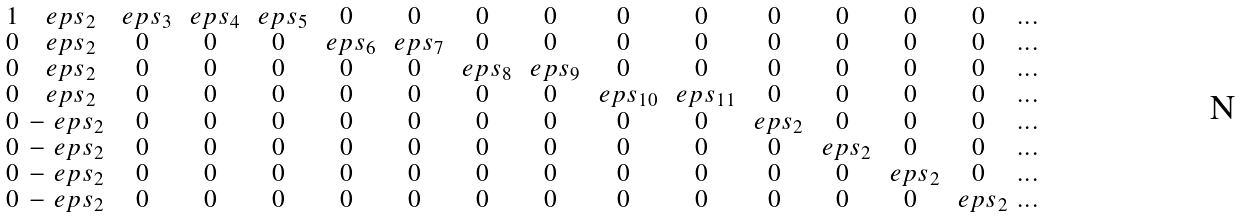Convert formula to latex. <formula><loc_0><loc_0><loc_500><loc_500>\begin{smallmatrix} 1 & \ e p s _ { 2 } & \ e p s _ { 3 } & \ e p s _ { 4 } & \ e p s _ { 5 } & 0 & 0 & 0 & 0 & 0 & 0 & 0 & 0 & 0 & 0 & \dots \\ 0 & \ e p s _ { 2 } & 0 & 0 & 0 & \ e p s _ { 6 } & \ e p s _ { 7 } & 0 & 0 & 0 & 0 & 0 & 0 & 0 & 0 & \dots \\ 0 & \ e p s _ { 2 } & 0 & 0 & 0 & 0 & 0 & \ e p s _ { 8 } & \ e p s _ { 9 } & 0 & 0 & 0 & 0 & 0 & 0 & \dots \\ 0 & \ e p s _ { 2 } & 0 & 0 & 0 & 0 & 0 & 0 & 0 & \ e p s _ { 1 0 } & \ e p s _ { 1 1 } & 0 & 0 & 0 & 0 & \dots \\ 0 & - \ e p s _ { 2 } & 0 & 0 & 0 & 0 & 0 & 0 & 0 & 0 & 0 & \ e p s _ { 2 } & 0 & 0 & 0 & \dots \\ 0 & - \ e p s _ { 2 } & 0 & 0 & 0 & 0 & 0 & 0 & 0 & 0 & 0 & 0 & \ e p s _ { 2 } & 0 & 0 & \dots \\ 0 & - \ e p s _ { 2 } & 0 & 0 & 0 & 0 & 0 & 0 & 0 & 0 & 0 & 0 & 0 & \ e p s _ { 2 } & 0 & \dots \\ 0 & - \ e p s _ { 2 } & 0 & 0 & 0 & 0 & 0 & 0 & 0 & 0 & 0 & 0 & 0 & 0 & \ e p s _ { 2 } & \dots \end{smallmatrix}</formula> 